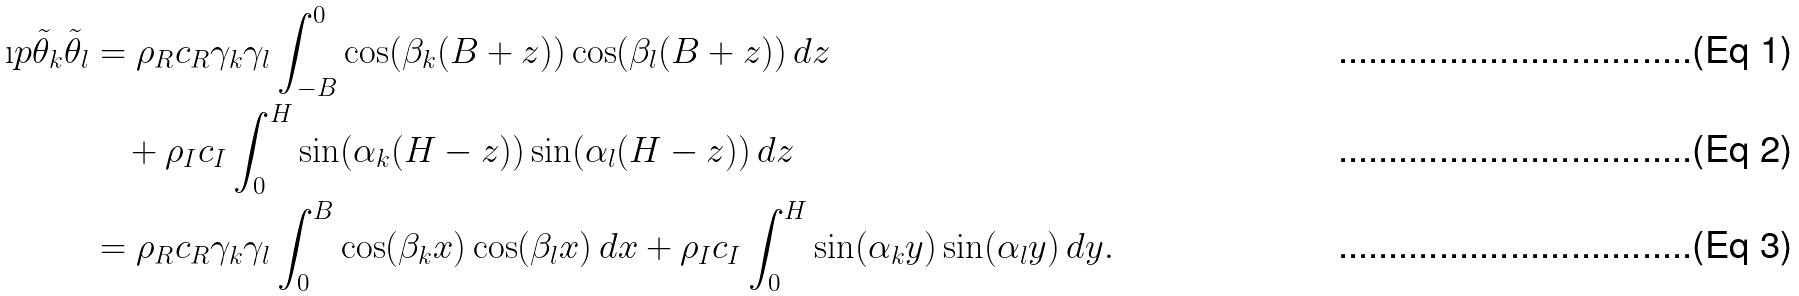<formula> <loc_0><loc_0><loc_500><loc_500>\i p { \tilde { \theta } _ { k } } { \tilde { \theta } _ { l } } & = \rho _ { R } c _ { R } \gamma _ { k } \gamma _ { l } \int _ { - B } ^ { 0 } \cos ( \beta _ { k } ( B + z ) ) \cos ( \beta _ { l } ( B + z ) ) \, d z \\ & \quad + \rho _ { I } c _ { I } \int _ { 0 } ^ { H } \sin ( \alpha _ { k } ( H - z ) ) \sin ( \alpha _ { l } ( H - z ) ) \, d z \\ & = \rho _ { R } c _ { R } \gamma _ { k } \gamma _ { l } \int _ { 0 } ^ { B } \cos ( \beta _ { k } x ) \cos ( \beta _ { l } x ) \, d x + \rho _ { I } c _ { I } \int _ { 0 } ^ { H } \sin ( \alpha _ { k } y ) \sin ( \alpha _ { l } y ) \, d y .</formula> 